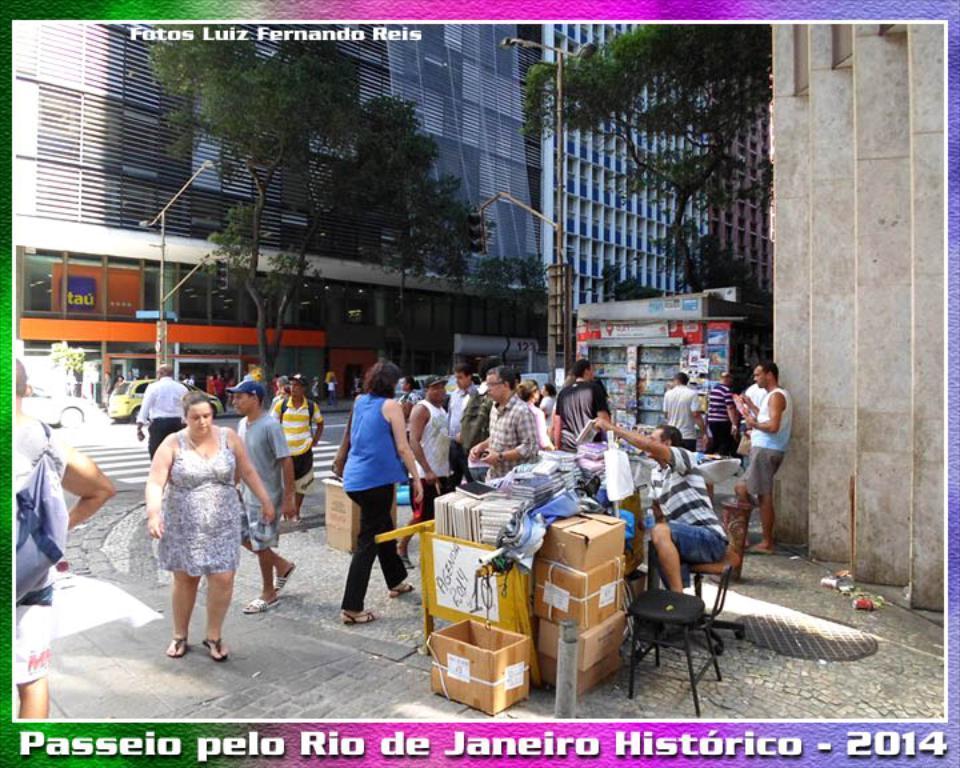Can you describe this image briefly? This is a poster. In the center of the image we can see some persons, boxes, books, cloths, boards, stores, buildings, poles, electric light poles, trees, wall. At the bottom of the image we can see road and some text. On the left side of the image we can see some vehicles. 